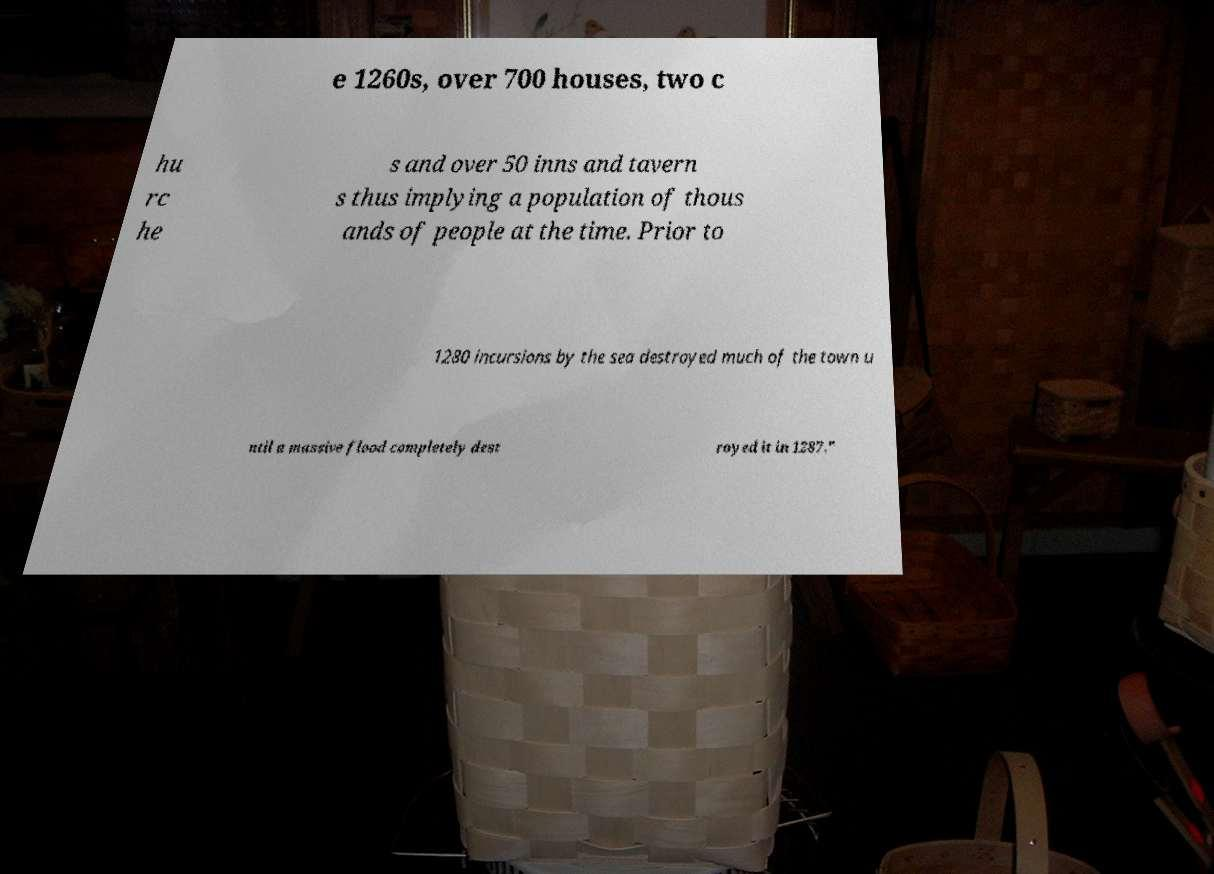For documentation purposes, I need the text within this image transcribed. Could you provide that? e 1260s, over 700 houses, two c hu rc he s and over 50 inns and tavern s thus implying a population of thous ands of people at the time. Prior to 1280 incursions by the sea destroyed much of the town u ntil a massive flood completely dest royed it in 1287." 